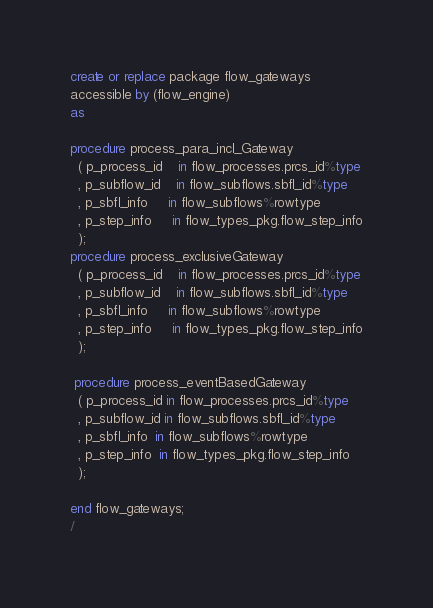<code> <loc_0><loc_0><loc_500><loc_500><_SQL_>create or replace package flow_gateways
accessible by (flow_engine)
as 

procedure process_para_incl_Gateway
  ( p_process_id    in flow_processes.prcs_id%type
  , p_subflow_id    in flow_subflows.sbfl_id%type
  , p_sbfl_info     in flow_subflows%rowtype
  , p_step_info     in flow_types_pkg.flow_step_info
  );
procedure process_exclusiveGateway
  ( p_process_id    in flow_processes.prcs_id%type
  , p_subflow_id    in flow_subflows.sbfl_id%type
  , p_sbfl_info     in flow_subflows%rowtype
  , p_step_info     in flow_types_pkg.flow_step_info
  );

 procedure process_eventBasedGateway
  ( p_process_id in flow_processes.prcs_id%type
  , p_subflow_id in flow_subflows.sbfl_id%type
  , p_sbfl_info  in flow_subflows%rowtype
  , p_step_info  in flow_types_pkg.flow_step_info
  );

end flow_gateways;
/
</code> 